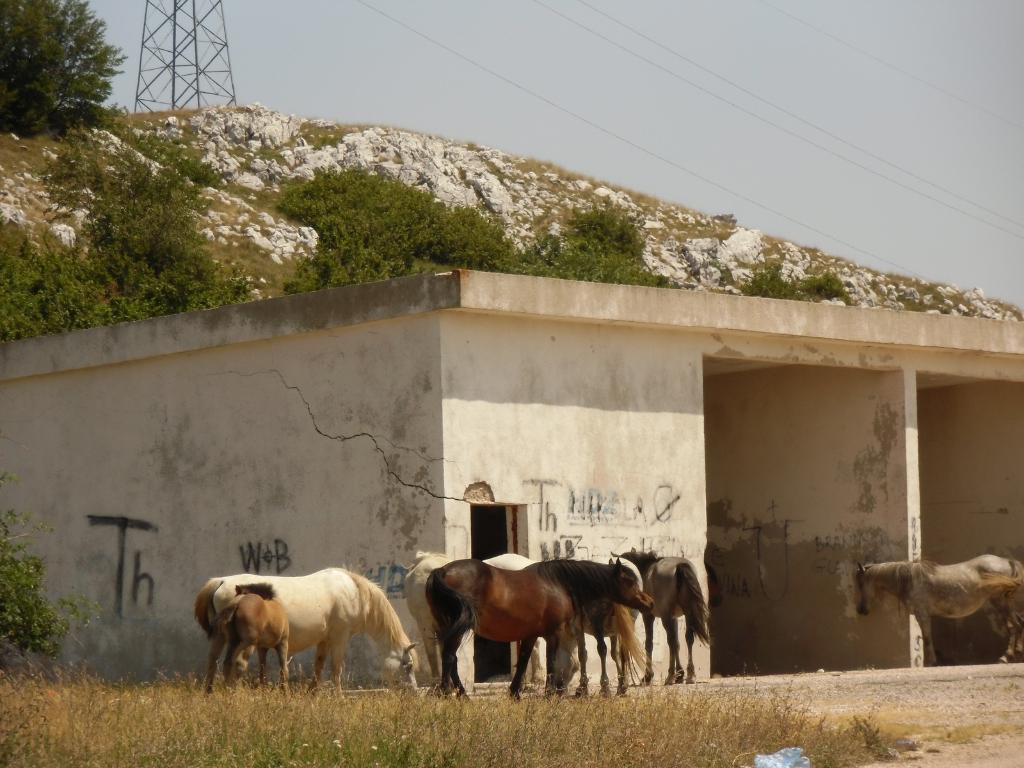Please provide a concise description of this image. In this image, we can see a shed and animals. In the background, there is a hill and we can see rocks, trees and a tower with poles. At the bottom, there is ground and some part of it is covered with grass. 